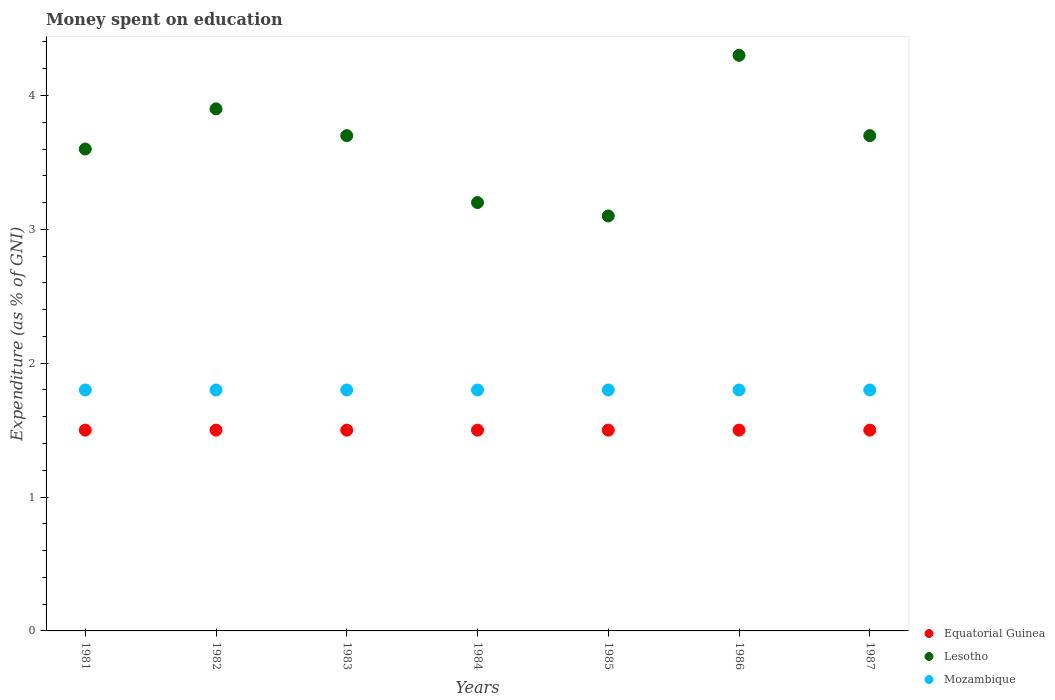Is the number of dotlines equal to the number of legend labels?
Your response must be concise. Yes. What is the amount of money spent on education in Mozambique in 1985?
Give a very brief answer. 1.8. Across all years, what is the maximum amount of money spent on education in Mozambique?
Offer a very short reply. 1.8. Across all years, what is the minimum amount of money spent on education in Equatorial Guinea?
Offer a very short reply. 1.5. In which year was the amount of money spent on education in Mozambique maximum?
Keep it short and to the point. 1981. What is the total amount of money spent on education in Mozambique in the graph?
Make the answer very short. 12.6. What is the difference between the amount of money spent on education in Lesotho in 1983 and that in 1986?
Make the answer very short. -0.6. What is the difference between the amount of money spent on education in Mozambique in 1985 and the amount of money spent on education in Lesotho in 1983?
Provide a succinct answer. -1.9. In the year 1983, what is the difference between the amount of money spent on education in Equatorial Guinea and amount of money spent on education in Lesotho?
Your answer should be very brief. -2.2. Is the amount of money spent on education in Equatorial Guinea in 1981 less than that in 1987?
Ensure brevity in your answer.  No. What is the difference between the highest and the second highest amount of money spent on education in Lesotho?
Give a very brief answer. 0.4. What is the difference between the highest and the lowest amount of money spent on education in Mozambique?
Keep it short and to the point. 0. Does the amount of money spent on education in Lesotho monotonically increase over the years?
Give a very brief answer. No. Is the amount of money spent on education in Equatorial Guinea strictly greater than the amount of money spent on education in Lesotho over the years?
Give a very brief answer. No. Is the amount of money spent on education in Lesotho strictly less than the amount of money spent on education in Mozambique over the years?
Provide a succinct answer. No. How many years are there in the graph?
Provide a short and direct response. 7. What is the difference between two consecutive major ticks on the Y-axis?
Make the answer very short. 1. Does the graph contain grids?
Your response must be concise. No. How many legend labels are there?
Offer a very short reply. 3. How are the legend labels stacked?
Your response must be concise. Vertical. What is the title of the graph?
Your answer should be compact. Money spent on education. Does "Upper middle income" appear as one of the legend labels in the graph?
Your response must be concise. No. What is the label or title of the Y-axis?
Your answer should be very brief. Expenditure (as % of GNI). What is the Expenditure (as % of GNI) of Equatorial Guinea in 1981?
Keep it short and to the point. 1.5. What is the Expenditure (as % of GNI) in Lesotho in 1981?
Keep it short and to the point. 3.6. What is the Expenditure (as % of GNI) in Equatorial Guinea in 1982?
Provide a succinct answer. 1.5. What is the Expenditure (as % of GNI) in Lesotho in 1982?
Your response must be concise. 3.9. What is the Expenditure (as % of GNI) of Mozambique in 1982?
Your answer should be compact. 1.8. What is the Expenditure (as % of GNI) of Equatorial Guinea in 1983?
Give a very brief answer. 1.5. What is the Expenditure (as % of GNI) of Lesotho in 1983?
Your response must be concise. 3.7. What is the Expenditure (as % of GNI) in Equatorial Guinea in 1984?
Your answer should be very brief. 1.5. What is the Expenditure (as % of GNI) of Lesotho in 1984?
Keep it short and to the point. 3.2. What is the Expenditure (as % of GNI) of Mozambique in 1984?
Your answer should be compact. 1.8. What is the Expenditure (as % of GNI) in Mozambique in 1985?
Keep it short and to the point. 1.8. What is the Expenditure (as % of GNI) in Lesotho in 1986?
Provide a succinct answer. 4.3. What is the Expenditure (as % of GNI) in Equatorial Guinea in 1987?
Your answer should be compact. 1.5. What is the Expenditure (as % of GNI) in Lesotho in 1987?
Give a very brief answer. 3.7. Across all years, what is the maximum Expenditure (as % of GNI) of Lesotho?
Offer a very short reply. 4.3. Across all years, what is the minimum Expenditure (as % of GNI) of Equatorial Guinea?
Your answer should be compact. 1.5. Across all years, what is the minimum Expenditure (as % of GNI) in Mozambique?
Keep it short and to the point. 1.8. What is the difference between the Expenditure (as % of GNI) in Mozambique in 1981 and that in 1982?
Your response must be concise. 0. What is the difference between the Expenditure (as % of GNI) in Lesotho in 1981 and that in 1983?
Provide a short and direct response. -0.1. What is the difference between the Expenditure (as % of GNI) of Mozambique in 1981 and that in 1983?
Your answer should be compact. 0. What is the difference between the Expenditure (as % of GNI) of Equatorial Guinea in 1981 and that in 1984?
Make the answer very short. 0. What is the difference between the Expenditure (as % of GNI) in Lesotho in 1981 and that in 1984?
Ensure brevity in your answer.  0.4. What is the difference between the Expenditure (as % of GNI) in Mozambique in 1981 and that in 1984?
Make the answer very short. 0. What is the difference between the Expenditure (as % of GNI) of Equatorial Guinea in 1981 and that in 1985?
Your answer should be compact. 0. What is the difference between the Expenditure (as % of GNI) in Mozambique in 1981 and that in 1985?
Ensure brevity in your answer.  0. What is the difference between the Expenditure (as % of GNI) of Equatorial Guinea in 1981 and that in 1987?
Offer a terse response. 0. What is the difference between the Expenditure (as % of GNI) in Lesotho in 1981 and that in 1987?
Your answer should be compact. -0.1. What is the difference between the Expenditure (as % of GNI) of Mozambique in 1981 and that in 1987?
Your answer should be compact. 0. What is the difference between the Expenditure (as % of GNI) of Equatorial Guinea in 1982 and that in 1984?
Offer a very short reply. 0. What is the difference between the Expenditure (as % of GNI) in Lesotho in 1982 and that in 1984?
Your answer should be very brief. 0.7. What is the difference between the Expenditure (as % of GNI) in Mozambique in 1982 and that in 1984?
Keep it short and to the point. 0. What is the difference between the Expenditure (as % of GNI) in Equatorial Guinea in 1982 and that in 1985?
Provide a succinct answer. 0. What is the difference between the Expenditure (as % of GNI) in Lesotho in 1982 and that in 1985?
Provide a short and direct response. 0.8. What is the difference between the Expenditure (as % of GNI) in Equatorial Guinea in 1982 and that in 1987?
Ensure brevity in your answer.  0. What is the difference between the Expenditure (as % of GNI) in Equatorial Guinea in 1983 and that in 1984?
Your answer should be very brief. 0. What is the difference between the Expenditure (as % of GNI) of Lesotho in 1983 and that in 1985?
Make the answer very short. 0.6. What is the difference between the Expenditure (as % of GNI) of Lesotho in 1983 and that in 1986?
Give a very brief answer. -0.6. What is the difference between the Expenditure (as % of GNI) of Mozambique in 1983 and that in 1987?
Make the answer very short. 0. What is the difference between the Expenditure (as % of GNI) of Mozambique in 1984 and that in 1985?
Provide a succinct answer. 0. What is the difference between the Expenditure (as % of GNI) of Lesotho in 1984 and that in 1986?
Your response must be concise. -1.1. What is the difference between the Expenditure (as % of GNI) of Lesotho in 1984 and that in 1987?
Offer a terse response. -0.5. What is the difference between the Expenditure (as % of GNI) in Mozambique in 1984 and that in 1987?
Make the answer very short. 0. What is the difference between the Expenditure (as % of GNI) in Mozambique in 1985 and that in 1986?
Provide a short and direct response. 0. What is the difference between the Expenditure (as % of GNI) of Lesotho in 1985 and that in 1987?
Your answer should be very brief. -0.6. What is the difference between the Expenditure (as % of GNI) in Equatorial Guinea in 1986 and that in 1987?
Provide a short and direct response. 0. What is the difference between the Expenditure (as % of GNI) of Lesotho in 1986 and that in 1987?
Your answer should be very brief. 0.6. What is the difference between the Expenditure (as % of GNI) in Mozambique in 1986 and that in 1987?
Give a very brief answer. 0. What is the difference between the Expenditure (as % of GNI) in Lesotho in 1981 and the Expenditure (as % of GNI) in Mozambique in 1982?
Ensure brevity in your answer.  1.8. What is the difference between the Expenditure (as % of GNI) in Lesotho in 1981 and the Expenditure (as % of GNI) in Mozambique in 1983?
Your response must be concise. 1.8. What is the difference between the Expenditure (as % of GNI) of Equatorial Guinea in 1981 and the Expenditure (as % of GNI) of Lesotho in 1985?
Keep it short and to the point. -1.6. What is the difference between the Expenditure (as % of GNI) of Lesotho in 1981 and the Expenditure (as % of GNI) of Mozambique in 1986?
Your response must be concise. 1.8. What is the difference between the Expenditure (as % of GNI) in Equatorial Guinea in 1981 and the Expenditure (as % of GNI) in Mozambique in 1987?
Give a very brief answer. -0.3. What is the difference between the Expenditure (as % of GNI) in Lesotho in 1981 and the Expenditure (as % of GNI) in Mozambique in 1987?
Your response must be concise. 1.8. What is the difference between the Expenditure (as % of GNI) in Equatorial Guinea in 1982 and the Expenditure (as % of GNI) in Mozambique in 1984?
Offer a terse response. -0.3. What is the difference between the Expenditure (as % of GNI) in Equatorial Guinea in 1982 and the Expenditure (as % of GNI) in Mozambique in 1985?
Offer a terse response. -0.3. What is the difference between the Expenditure (as % of GNI) in Lesotho in 1982 and the Expenditure (as % of GNI) in Mozambique in 1985?
Ensure brevity in your answer.  2.1. What is the difference between the Expenditure (as % of GNI) of Equatorial Guinea in 1982 and the Expenditure (as % of GNI) of Lesotho in 1986?
Provide a succinct answer. -2.8. What is the difference between the Expenditure (as % of GNI) of Equatorial Guinea in 1982 and the Expenditure (as % of GNI) of Lesotho in 1987?
Keep it short and to the point. -2.2. What is the difference between the Expenditure (as % of GNI) of Lesotho in 1982 and the Expenditure (as % of GNI) of Mozambique in 1987?
Offer a very short reply. 2.1. What is the difference between the Expenditure (as % of GNI) in Equatorial Guinea in 1983 and the Expenditure (as % of GNI) in Mozambique in 1984?
Offer a terse response. -0.3. What is the difference between the Expenditure (as % of GNI) in Lesotho in 1983 and the Expenditure (as % of GNI) in Mozambique in 1984?
Offer a very short reply. 1.9. What is the difference between the Expenditure (as % of GNI) in Equatorial Guinea in 1983 and the Expenditure (as % of GNI) in Lesotho in 1985?
Make the answer very short. -1.6. What is the difference between the Expenditure (as % of GNI) in Equatorial Guinea in 1983 and the Expenditure (as % of GNI) in Mozambique in 1985?
Offer a terse response. -0.3. What is the difference between the Expenditure (as % of GNI) in Lesotho in 1983 and the Expenditure (as % of GNI) in Mozambique in 1985?
Offer a very short reply. 1.9. What is the difference between the Expenditure (as % of GNI) in Equatorial Guinea in 1983 and the Expenditure (as % of GNI) in Lesotho in 1986?
Make the answer very short. -2.8. What is the difference between the Expenditure (as % of GNI) of Lesotho in 1983 and the Expenditure (as % of GNI) of Mozambique in 1987?
Offer a very short reply. 1.9. What is the difference between the Expenditure (as % of GNI) of Equatorial Guinea in 1984 and the Expenditure (as % of GNI) of Lesotho in 1985?
Offer a very short reply. -1.6. What is the difference between the Expenditure (as % of GNI) of Equatorial Guinea in 1984 and the Expenditure (as % of GNI) of Mozambique in 1985?
Keep it short and to the point. -0.3. What is the difference between the Expenditure (as % of GNI) of Lesotho in 1984 and the Expenditure (as % of GNI) of Mozambique in 1985?
Offer a terse response. 1.4. What is the difference between the Expenditure (as % of GNI) in Equatorial Guinea in 1985 and the Expenditure (as % of GNI) in Lesotho in 1986?
Make the answer very short. -2.8. What is the difference between the Expenditure (as % of GNI) in Lesotho in 1985 and the Expenditure (as % of GNI) in Mozambique in 1986?
Ensure brevity in your answer.  1.3. What is the difference between the Expenditure (as % of GNI) in Lesotho in 1985 and the Expenditure (as % of GNI) in Mozambique in 1987?
Provide a short and direct response. 1.3. What is the difference between the Expenditure (as % of GNI) of Equatorial Guinea in 1986 and the Expenditure (as % of GNI) of Lesotho in 1987?
Your answer should be very brief. -2.2. What is the average Expenditure (as % of GNI) of Lesotho per year?
Provide a short and direct response. 3.64. In the year 1981, what is the difference between the Expenditure (as % of GNI) in Equatorial Guinea and Expenditure (as % of GNI) in Lesotho?
Your answer should be very brief. -2.1. In the year 1983, what is the difference between the Expenditure (as % of GNI) in Equatorial Guinea and Expenditure (as % of GNI) in Mozambique?
Keep it short and to the point. -0.3. In the year 1983, what is the difference between the Expenditure (as % of GNI) of Lesotho and Expenditure (as % of GNI) of Mozambique?
Ensure brevity in your answer.  1.9. In the year 1984, what is the difference between the Expenditure (as % of GNI) of Equatorial Guinea and Expenditure (as % of GNI) of Mozambique?
Provide a succinct answer. -0.3. In the year 1984, what is the difference between the Expenditure (as % of GNI) in Lesotho and Expenditure (as % of GNI) in Mozambique?
Ensure brevity in your answer.  1.4. In the year 1985, what is the difference between the Expenditure (as % of GNI) of Equatorial Guinea and Expenditure (as % of GNI) of Lesotho?
Your answer should be compact. -1.6. In the year 1985, what is the difference between the Expenditure (as % of GNI) in Lesotho and Expenditure (as % of GNI) in Mozambique?
Provide a succinct answer. 1.3. In the year 1987, what is the difference between the Expenditure (as % of GNI) of Equatorial Guinea and Expenditure (as % of GNI) of Lesotho?
Give a very brief answer. -2.2. What is the ratio of the Expenditure (as % of GNI) of Equatorial Guinea in 1981 to that in 1982?
Keep it short and to the point. 1. What is the ratio of the Expenditure (as % of GNI) in Lesotho in 1981 to that in 1982?
Ensure brevity in your answer.  0.92. What is the ratio of the Expenditure (as % of GNI) of Mozambique in 1981 to that in 1982?
Ensure brevity in your answer.  1. What is the ratio of the Expenditure (as % of GNI) in Equatorial Guinea in 1981 to that in 1983?
Ensure brevity in your answer.  1. What is the ratio of the Expenditure (as % of GNI) of Lesotho in 1981 to that in 1983?
Provide a succinct answer. 0.97. What is the ratio of the Expenditure (as % of GNI) in Mozambique in 1981 to that in 1983?
Ensure brevity in your answer.  1. What is the ratio of the Expenditure (as % of GNI) in Equatorial Guinea in 1981 to that in 1984?
Keep it short and to the point. 1. What is the ratio of the Expenditure (as % of GNI) in Equatorial Guinea in 1981 to that in 1985?
Ensure brevity in your answer.  1. What is the ratio of the Expenditure (as % of GNI) of Lesotho in 1981 to that in 1985?
Keep it short and to the point. 1.16. What is the ratio of the Expenditure (as % of GNI) in Equatorial Guinea in 1981 to that in 1986?
Make the answer very short. 1. What is the ratio of the Expenditure (as % of GNI) in Lesotho in 1981 to that in 1986?
Give a very brief answer. 0.84. What is the ratio of the Expenditure (as % of GNI) in Mozambique in 1981 to that in 1986?
Provide a short and direct response. 1. What is the ratio of the Expenditure (as % of GNI) of Equatorial Guinea in 1981 to that in 1987?
Offer a very short reply. 1. What is the ratio of the Expenditure (as % of GNI) in Equatorial Guinea in 1982 to that in 1983?
Your answer should be very brief. 1. What is the ratio of the Expenditure (as % of GNI) in Lesotho in 1982 to that in 1983?
Make the answer very short. 1.05. What is the ratio of the Expenditure (as % of GNI) in Mozambique in 1982 to that in 1983?
Ensure brevity in your answer.  1. What is the ratio of the Expenditure (as % of GNI) in Lesotho in 1982 to that in 1984?
Offer a terse response. 1.22. What is the ratio of the Expenditure (as % of GNI) of Equatorial Guinea in 1982 to that in 1985?
Offer a very short reply. 1. What is the ratio of the Expenditure (as % of GNI) of Lesotho in 1982 to that in 1985?
Your answer should be very brief. 1.26. What is the ratio of the Expenditure (as % of GNI) of Lesotho in 1982 to that in 1986?
Your response must be concise. 0.91. What is the ratio of the Expenditure (as % of GNI) of Mozambique in 1982 to that in 1986?
Provide a short and direct response. 1. What is the ratio of the Expenditure (as % of GNI) of Lesotho in 1982 to that in 1987?
Give a very brief answer. 1.05. What is the ratio of the Expenditure (as % of GNI) of Equatorial Guinea in 1983 to that in 1984?
Your answer should be compact. 1. What is the ratio of the Expenditure (as % of GNI) in Lesotho in 1983 to that in 1984?
Make the answer very short. 1.16. What is the ratio of the Expenditure (as % of GNI) in Mozambique in 1983 to that in 1984?
Offer a terse response. 1. What is the ratio of the Expenditure (as % of GNI) in Equatorial Guinea in 1983 to that in 1985?
Make the answer very short. 1. What is the ratio of the Expenditure (as % of GNI) of Lesotho in 1983 to that in 1985?
Give a very brief answer. 1.19. What is the ratio of the Expenditure (as % of GNI) of Lesotho in 1983 to that in 1986?
Provide a short and direct response. 0.86. What is the ratio of the Expenditure (as % of GNI) of Mozambique in 1983 to that in 1986?
Offer a very short reply. 1. What is the ratio of the Expenditure (as % of GNI) in Equatorial Guinea in 1983 to that in 1987?
Your answer should be very brief. 1. What is the ratio of the Expenditure (as % of GNI) of Mozambique in 1983 to that in 1987?
Give a very brief answer. 1. What is the ratio of the Expenditure (as % of GNI) in Lesotho in 1984 to that in 1985?
Your answer should be very brief. 1.03. What is the ratio of the Expenditure (as % of GNI) of Mozambique in 1984 to that in 1985?
Your response must be concise. 1. What is the ratio of the Expenditure (as % of GNI) in Equatorial Guinea in 1984 to that in 1986?
Keep it short and to the point. 1. What is the ratio of the Expenditure (as % of GNI) of Lesotho in 1984 to that in 1986?
Ensure brevity in your answer.  0.74. What is the ratio of the Expenditure (as % of GNI) in Lesotho in 1984 to that in 1987?
Give a very brief answer. 0.86. What is the ratio of the Expenditure (as % of GNI) in Mozambique in 1984 to that in 1987?
Make the answer very short. 1. What is the ratio of the Expenditure (as % of GNI) in Lesotho in 1985 to that in 1986?
Ensure brevity in your answer.  0.72. What is the ratio of the Expenditure (as % of GNI) in Mozambique in 1985 to that in 1986?
Keep it short and to the point. 1. What is the ratio of the Expenditure (as % of GNI) of Equatorial Guinea in 1985 to that in 1987?
Your answer should be compact. 1. What is the ratio of the Expenditure (as % of GNI) in Lesotho in 1985 to that in 1987?
Your answer should be very brief. 0.84. What is the ratio of the Expenditure (as % of GNI) of Equatorial Guinea in 1986 to that in 1987?
Your answer should be compact. 1. What is the ratio of the Expenditure (as % of GNI) of Lesotho in 1986 to that in 1987?
Provide a short and direct response. 1.16. What is the ratio of the Expenditure (as % of GNI) of Mozambique in 1986 to that in 1987?
Make the answer very short. 1. What is the difference between the highest and the second highest Expenditure (as % of GNI) in Equatorial Guinea?
Give a very brief answer. 0. What is the difference between the highest and the second highest Expenditure (as % of GNI) of Mozambique?
Offer a very short reply. 0. What is the difference between the highest and the lowest Expenditure (as % of GNI) in Equatorial Guinea?
Make the answer very short. 0. What is the difference between the highest and the lowest Expenditure (as % of GNI) of Mozambique?
Offer a very short reply. 0. 